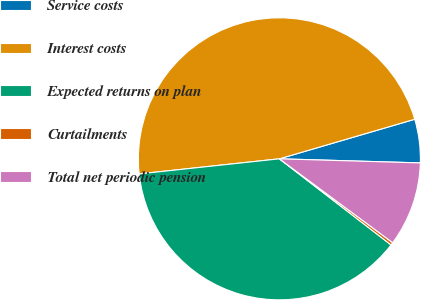<chart> <loc_0><loc_0><loc_500><loc_500><pie_chart><fcel>Service costs<fcel>Interest costs<fcel>Expected returns on plan<fcel>Curtailments<fcel>Total net periodic pension<nl><fcel>4.99%<fcel>47.18%<fcel>37.84%<fcel>0.31%<fcel>9.68%<nl></chart> 